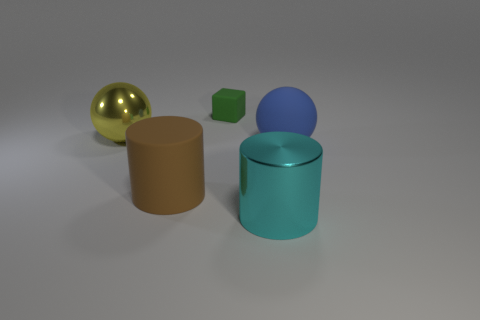How many other objects are the same material as the blue object?
Make the answer very short. 2. Is the size of the green cube the same as the matte sphere that is in front of the green thing?
Make the answer very short. No. The tiny cube has what color?
Offer a terse response. Green. There is a big metallic object behind the shiny object in front of the shiny object that is left of the cyan thing; what is its shape?
Your response must be concise. Sphere. There is a cylinder that is right of the cylinder that is behind the large metal cylinder; what is it made of?
Offer a very short reply. Metal. There is a yellow thing that is the same material as the cyan cylinder; what shape is it?
Ensure brevity in your answer.  Sphere. Is there any other thing that has the same shape as the yellow metallic object?
Provide a short and direct response. Yes. What number of rubber cubes are to the left of the metal ball?
Keep it short and to the point. 0. Is there a big matte ball?
Ensure brevity in your answer.  Yes. What color is the large ball that is left of the large rubber thing that is in front of the sphere that is in front of the big yellow metallic sphere?
Your answer should be compact. Yellow. 